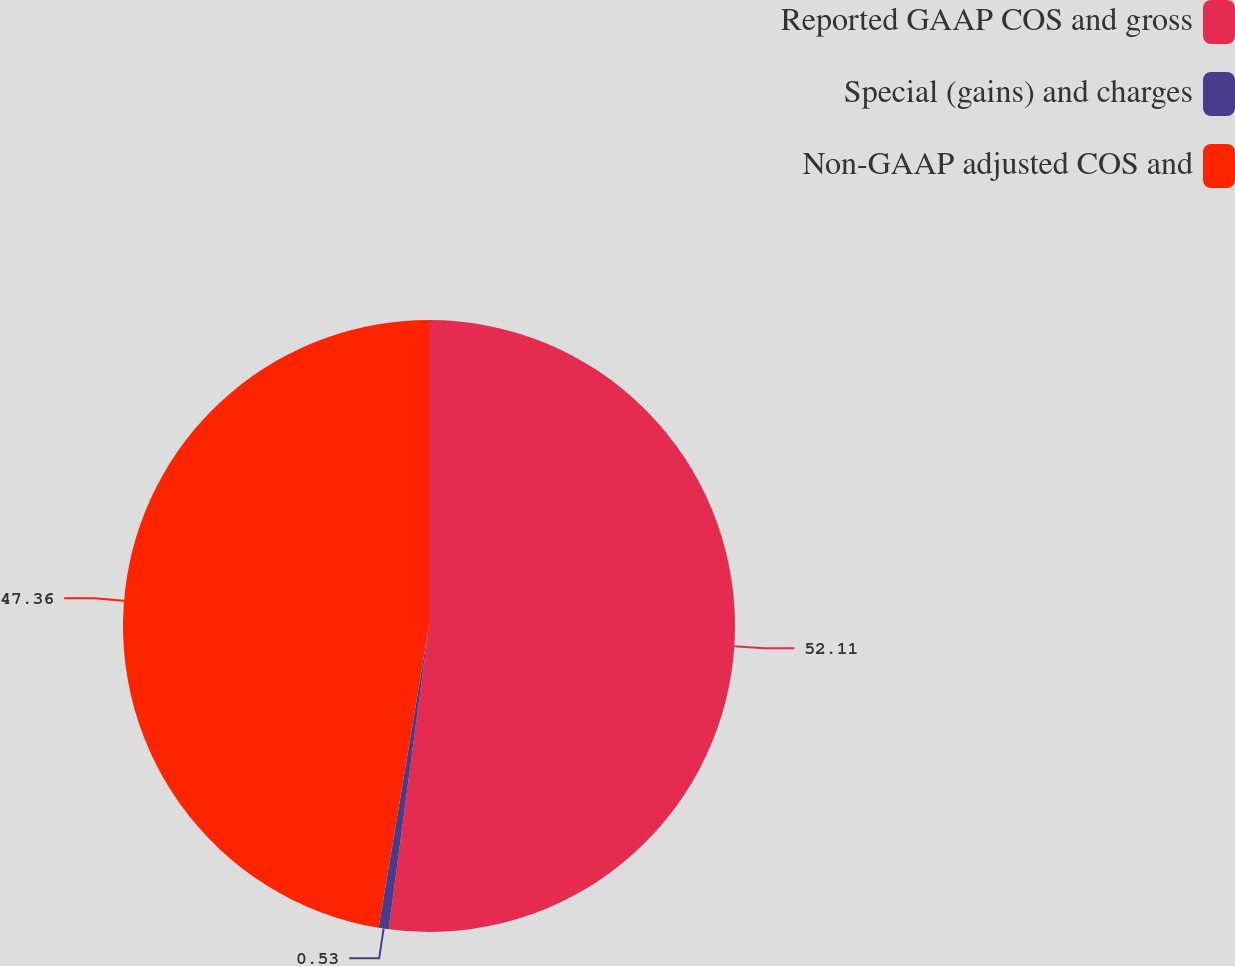Convert chart. <chart><loc_0><loc_0><loc_500><loc_500><pie_chart><fcel>Reported GAAP COS and gross<fcel>Special (gains) and charges<fcel>Non-GAAP adjusted COS and<nl><fcel>52.1%<fcel>0.53%<fcel>47.36%<nl></chart> 